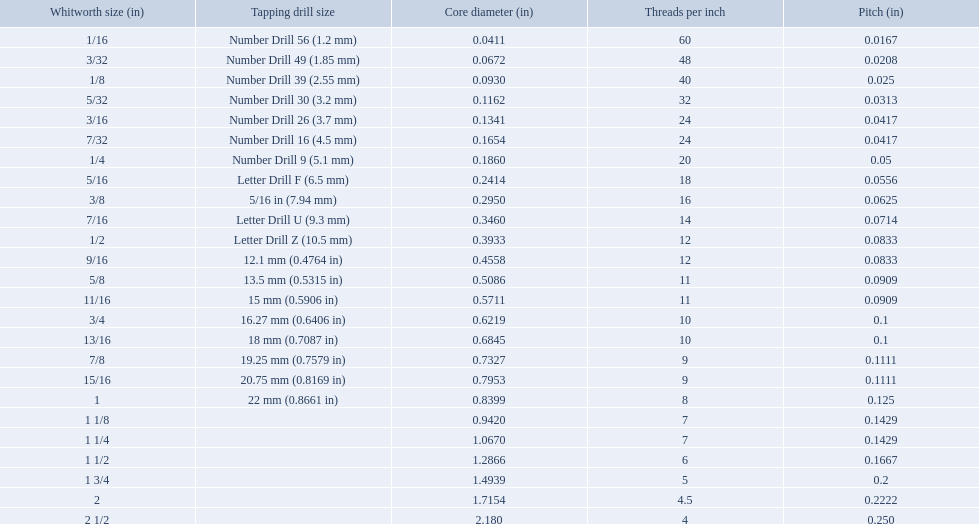What are all the whitworth sizes? 1/16, 3/32, 1/8, 5/32, 3/16, 7/32, 1/4, 5/16, 3/8, 7/16, 1/2, 9/16, 5/8, 11/16, 3/4, 13/16, 7/8, 15/16, 1, 1 1/8, 1 1/4, 1 1/2, 1 3/4, 2, 2 1/2. What are the threads per inch of these sizes? 60, 48, 40, 32, 24, 24, 20, 18, 16, 14, 12, 12, 11, 11, 10, 10, 9, 9, 8, 7, 7, 6, 5, 4.5, 4. Of these, which are 5? 5. What whitworth size has this threads per inch? 1 3/4. What are all of the whitworth sizes? 1/16, 3/32, 1/8, 5/32, 3/16, 7/32, 1/4, 5/16, 3/8, 7/16, 1/2, 9/16, 5/8, 11/16, 3/4, 13/16, 7/8, 15/16, 1, 1 1/8, 1 1/4, 1 1/2, 1 3/4, 2, 2 1/2. How many threads per inch are in each size? 60, 48, 40, 32, 24, 24, 20, 18, 16, 14, 12, 12, 11, 11, 10, 10, 9, 9, 8, 7, 7, 6, 5, 4.5, 4. How many threads per inch are in the 3/16 size? 24. And which other size has the same number of threads? 7/32. 